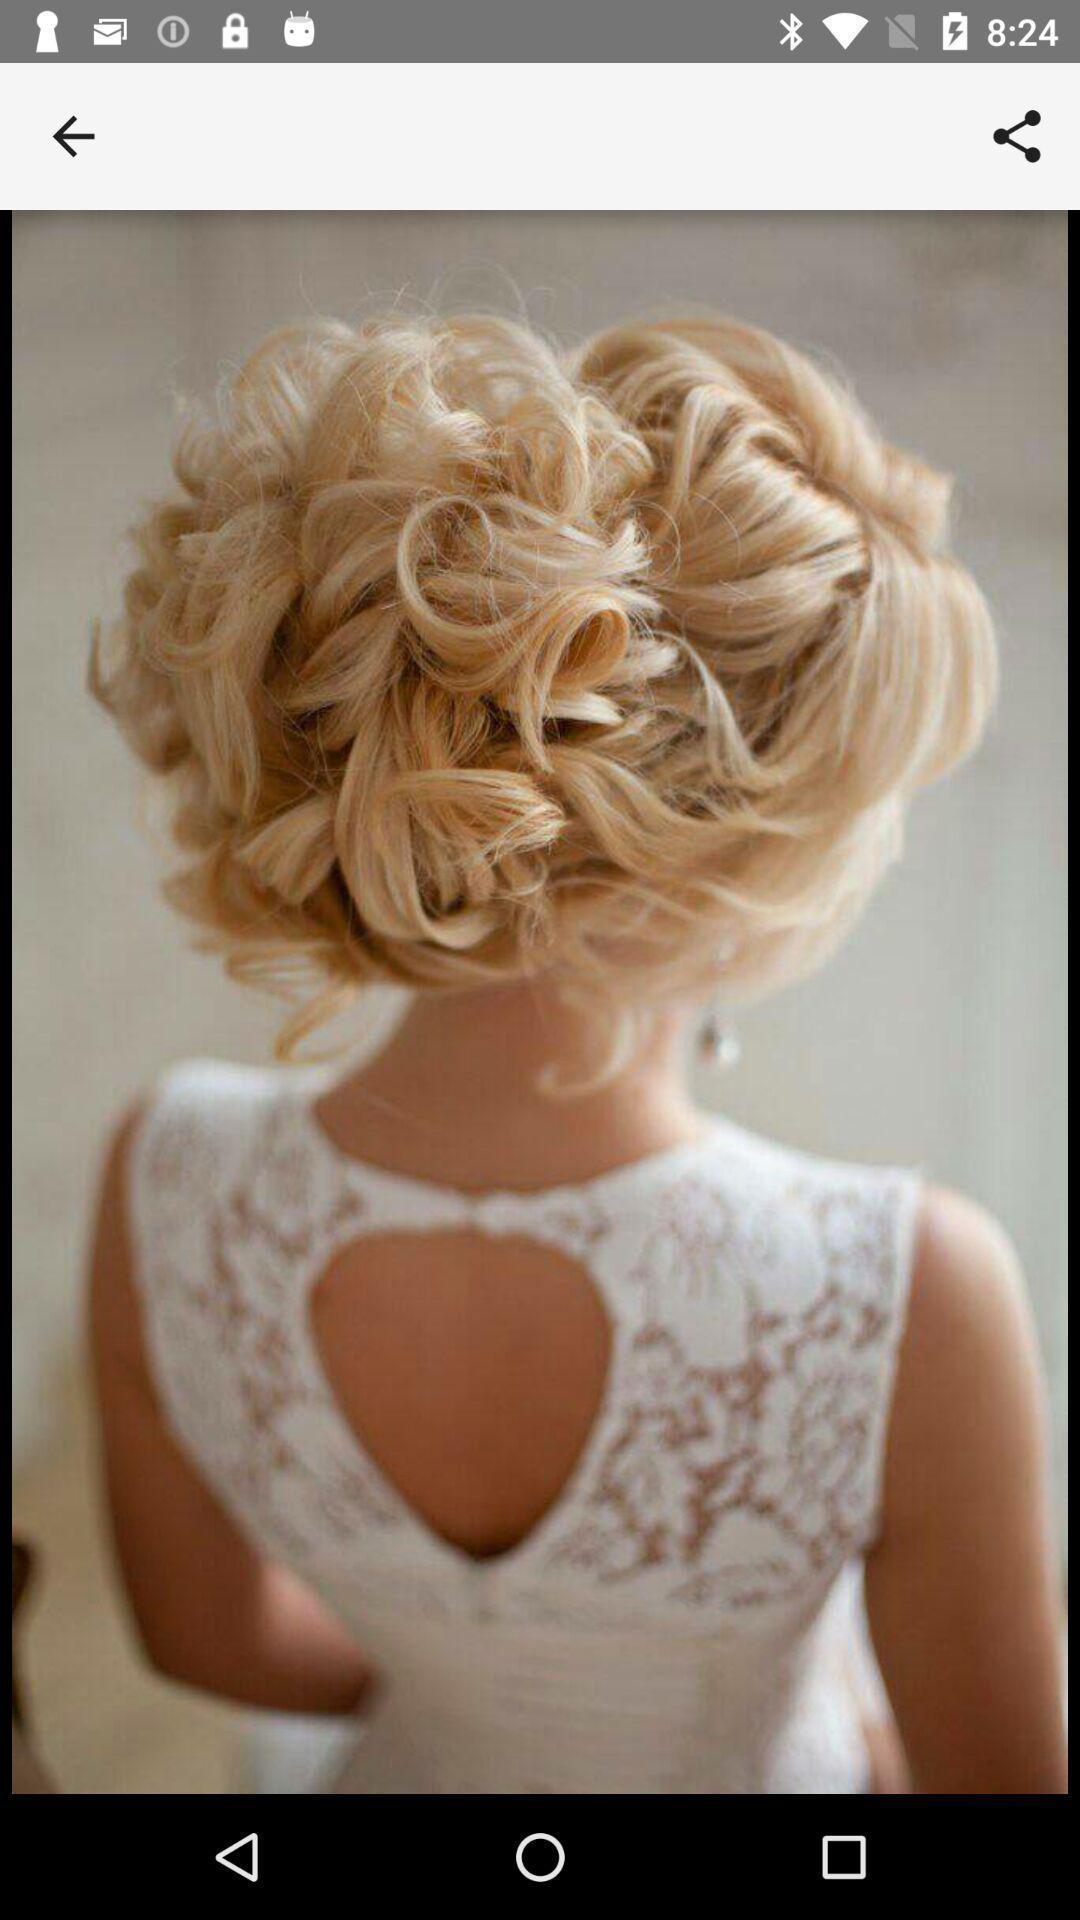What can you discern from this picture? Screen showing image of hair style in a beauty app. 